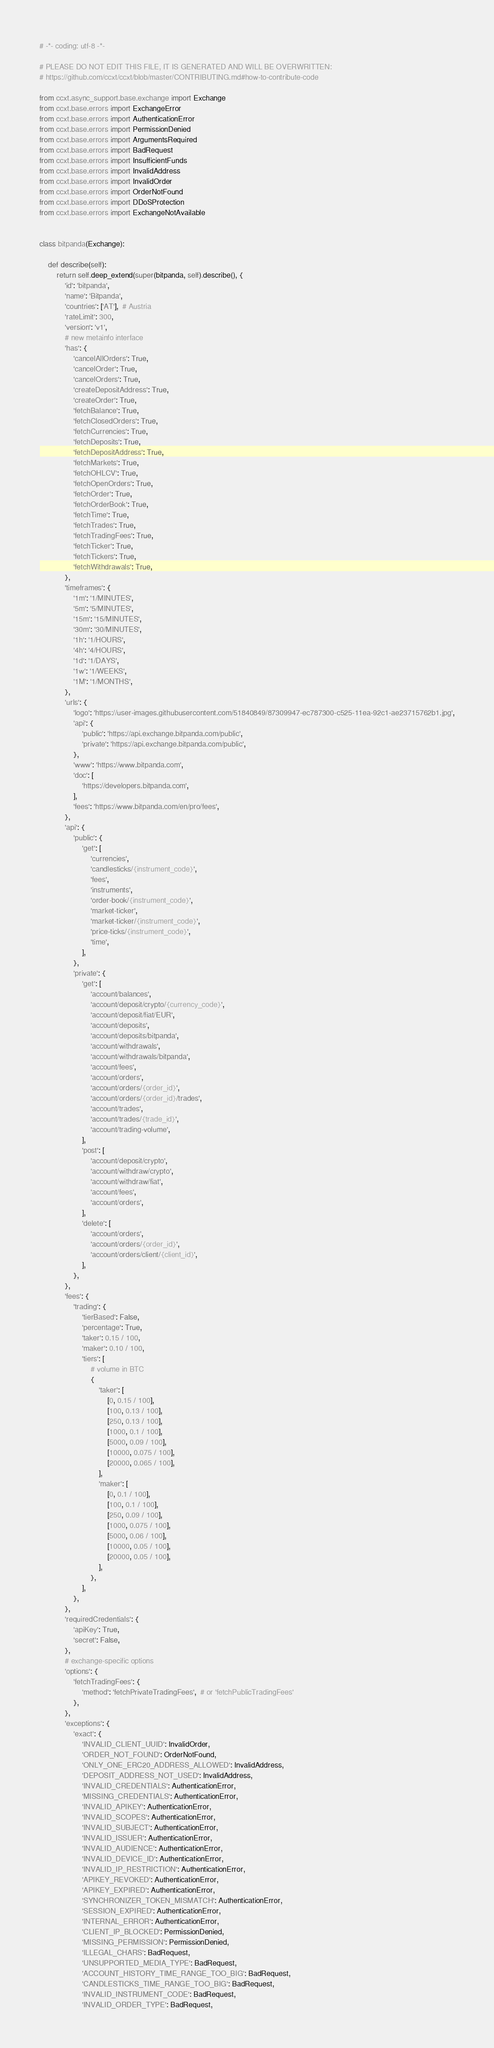<code> <loc_0><loc_0><loc_500><loc_500><_Python_># -*- coding: utf-8 -*-

# PLEASE DO NOT EDIT THIS FILE, IT IS GENERATED AND WILL BE OVERWRITTEN:
# https://github.com/ccxt/ccxt/blob/master/CONTRIBUTING.md#how-to-contribute-code

from ccxt.async_support.base.exchange import Exchange
from ccxt.base.errors import ExchangeError
from ccxt.base.errors import AuthenticationError
from ccxt.base.errors import PermissionDenied
from ccxt.base.errors import ArgumentsRequired
from ccxt.base.errors import BadRequest
from ccxt.base.errors import InsufficientFunds
from ccxt.base.errors import InvalidAddress
from ccxt.base.errors import InvalidOrder
from ccxt.base.errors import OrderNotFound
from ccxt.base.errors import DDoSProtection
from ccxt.base.errors import ExchangeNotAvailable


class bitpanda(Exchange):

    def describe(self):
        return self.deep_extend(super(bitpanda, self).describe(), {
            'id': 'bitpanda',
            'name': 'Bitpanda',
            'countries': ['AT'],  # Austria
            'rateLimit': 300,
            'version': 'v1',
            # new metainfo interface
            'has': {
                'cancelAllOrders': True,
                'cancelOrder': True,
                'cancelOrders': True,
                'createDepositAddress': True,
                'createOrder': True,
                'fetchBalance': True,
                'fetchClosedOrders': True,
                'fetchCurrencies': True,
                'fetchDeposits': True,
                'fetchDepositAddress': True,
                'fetchMarkets': True,
                'fetchOHLCV': True,
                'fetchOpenOrders': True,
                'fetchOrder': True,
                'fetchOrderBook': True,
                'fetchTime': True,
                'fetchTrades': True,
                'fetchTradingFees': True,
                'fetchTicker': True,
                'fetchTickers': True,
                'fetchWithdrawals': True,
            },
            'timeframes': {
                '1m': '1/MINUTES',
                '5m': '5/MINUTES',
                '15m': '15/MINUTES',
                '30m': '30/MINUTES',
                '1h': '1/HOURS',
                '4h': '4/HOURS',
                '1d': '1/DAYS',
                '1w': '1/WEEKS',
                '1M': '1/MONTHS',
            },
            'urls': {
                'logo': 'https://user-images.githubusercontent.com/51840849/87309947-ec787300-c525-11ea-92c1-ae23715762b1.jpg',
                'api': {
                    'public': 'https://api.exchange.bitpanda.com/public',
                    'private': 'https://api.exchange.bitpanda.com/public',
                },
                'www': 'https://www.bitpanda.com',
                'doc': [
                    'https://developers.bitpanda.com',
                ],
                'fees': 'https://www.bitpanda.com/en/pro/fees',
            },
            'api': {
                'public': {
                    'get': [
                        'currencies',
                        'candlesticks/{instrument_code}',
                        'fees',
                        'instruments',
                        'order-book/{instrument_code}',
                        'market-ticker',
                        'market-ticker/{instrument_code}',
                        'price-ticks/{instrument_code}',
                        'time',
                    ],
                },
                'private': {
                    'get': [
                        'account/balances',
                        'account/deposit/crypto/{currency_code}',
                        'account/deposit/fiat/EUR',
                        'account/deposits',
                        'account/deposits/bitpanda',
                        'account/withdrawals',
                        'account/withdrawals/bitpanda',
                        'account/fees',
                        'account/orders',
                        'account/orders/{order_id}',
                        'account/orders/{order_id}/trades',
                        'account/trades',
                        'account/trades/{trade_id}',
                        'account/trading-volume',
                    ],
                    'post': [
                        'account/deposit/crypto',
                        'account/withdraw/crypto',
                        'account/withdraw/fiat',
                        'account/fees',
                        'account/orders',
                    ],
                    'delete': [
                        'account/orders',
                        'account/orders/{order_id}',
                        'account/orders/client/{client_id}',
                    ],
                },
            },
            'fees': {
                'trading': {
                    'tierBased': False,
                    'percentage': True,
                    'taker': 0.15 / 100,
                    'maker': 0.10 / 100,
                    'tiers': [
                        # volume in BTC
                        {
                            'taker': [
                                [0, 0.15 / 100],
                                [100, 0.13 / 100],
                                [250, 0.13 / 100],
                                [1000, 0.1 / 100],
                                [5000, 0.09 / 100],
                                [10000, 0.075 / 100],
                                [20000, 0.065 / 100],
                            ],
                            'maker': [
                                [0, 0.1 / 100],
                                [100, 0.1 / 100],
                                [250, 0.09 / 100],
                                [1000, 0.075 / 100],
                                [5000, 0.06 / 100],
                                [10000, 0.05 / 100],
                                [20000, 0.05 / 100],
                            ],
                        },
                    ],
                },
            },
            'requiredCredentials': {
                'apiKey': True,
                'secret': False,
            },
            # exchange-specific options
            'options': {
                'fetchTradingFees': {
                    'method': 'fetchPrivateTradingFees',  # or 'fetchPublicTradingFees'
                },
            },
            'exceptions': {
                'exact': {
                    'INVALID_CLIENT_UUID': InvalidOrder,
                    'ORDER_NOT_FOUND': OrderNotFound,
                    'ONLY_ONE_ERC20_ADDRESS_ALLOWED': InvalidAddress,
                    'DEPOSIT_ADDRESS_NOT_USED': InvalidAddress,
                    'INVALID_CREDENTIALS': AuthenticationError,
                    'MISSING_CREDENTIALS': AuthenticationError,
                    'INVALID_APIKEY': AuthenticationError,
                    'INVALID_SCOPES': AuthenticationError,
                    'INVALID_SUBJECT': AuthenticationError,
                    'INVALID_ISSUER': AuthenticationError,
                    'INVALID_AUDIENCE': AuthenticationError,
                    'INVALID_DEVICE_ID': AuthenticationError,
                    'INVALID_IP_RESTRICTION': AuthenticationError,
                    'APIKEY_REVOKED': AuthenticationError,
                    'APIKEY_EXPIRED': AuthenticationError,
                    'SYNCHRONIZER_TOKEN_MISMATCH': AuthenticationError,
                    'SESSION_EXPIRED': AuthenticationError,
                    'INTERNAL_ERROR': AuthenticationError,
                    'CLIENT_IP_BLOCKED': PermissionDenied,
                    'MISSING_PERMISSION': PermissionDenied,
                    'ILLEGAL_CHARS': BadRequest,
                    'UNSUPPORTED_MEDIA_TYPE': BadRequest,
                    'ACCOUNT_HISTORY_TIME_RANGE_TOO_BIG': BadRequest,
                    'CANDLESTICKS_TIME_RANGE_TOO_BIG': BadRequest,
                    'INVALID_INSTRUMENT_CODE': BadRequest,
                    'INVALID_ORDER_TYPE': BadRequest,</code> 